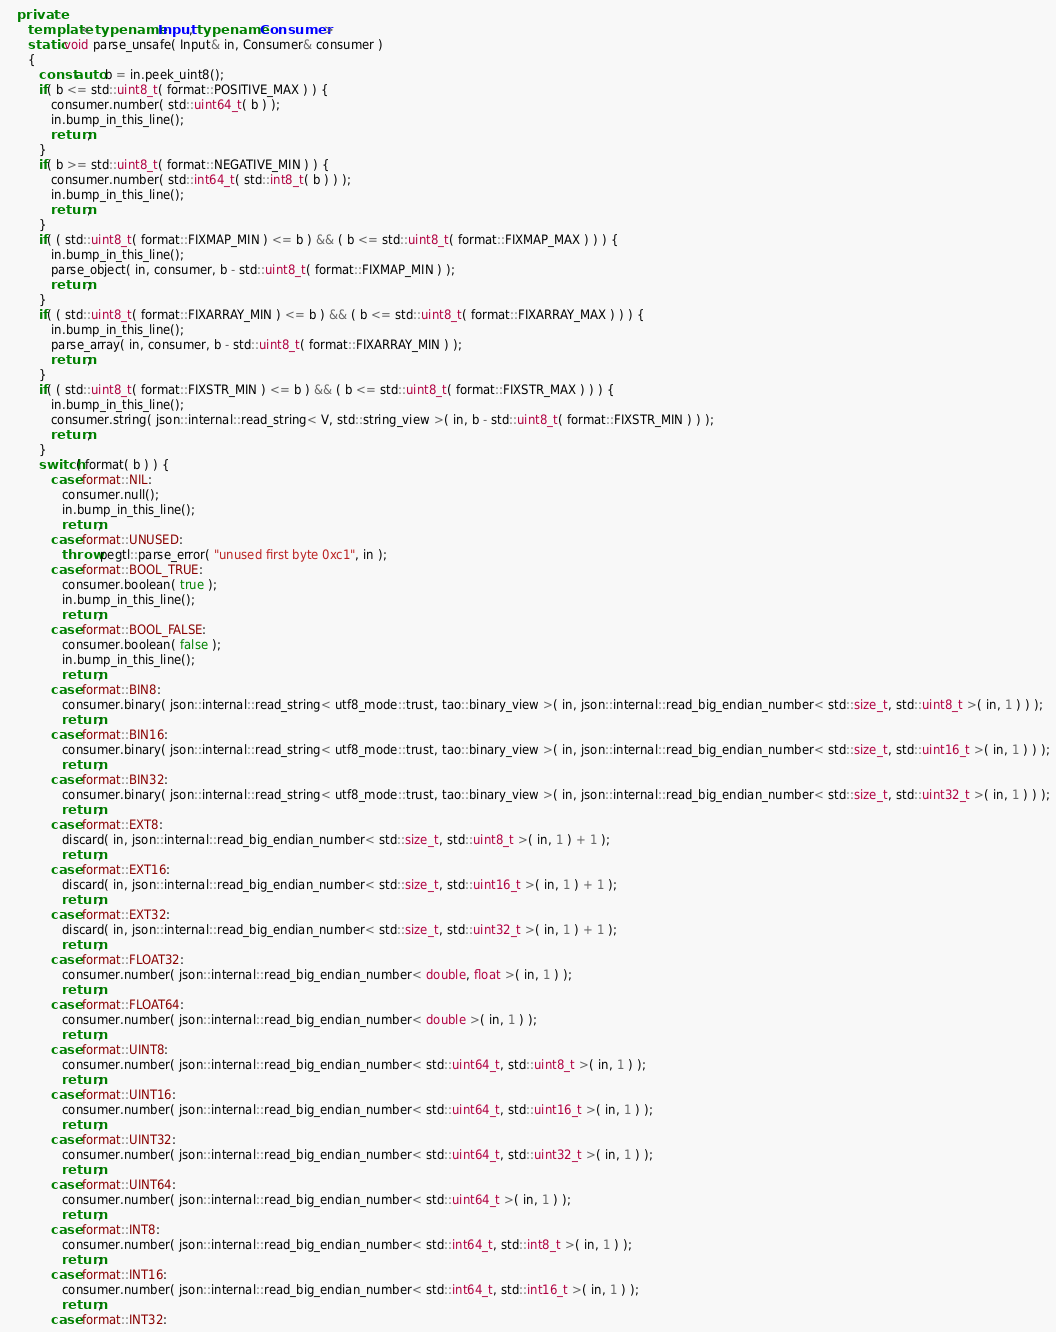Convert code to text. <code><loc_0><loc_0><loc_500><loc_500><_C++_>   private:
      template< typename Input, typename Consumer >
      static void parse_unsafe( Input& in, Consumer& consumer )
      {
         const auto b = in.peek_uint8();
         if( b <= std::uint8_t( format::POSITIVE_MAX ) ) {
            consumer.number( std::uint64_t( b ) );
            in.bump_in_this_line();
            return;
         }
         if( b >= std::uint8_t( format::NEGATIVE_MIN ) ) {
            consumer.number( std::int64_t( std::int8_t( b ) ) );
            in.bump_in_this_line();
            return;
         }
         if( ( std::uint8_t( format::FIXMAP_MIN ) <= b ) && ( b <= std::uint8_t( format::FIXMAP_MAX ) ) ) {
            in.bump_in_this_line();
            parse_object( in, consumer, b - std::uint8_t( format::FIXMAP_MIN ) );
            return;
         }
         if( ( std::uint8_t( format::FIXARRAY_MIN ) <= b ) && ( b <= std::uint8_t( format::FIXARRAY_MAX ) ) ) {
            in.bump_in_this_line();
            parse_array( in, consumer, b - std::uint8_t( format::FIXARRAY_MIN ) );
            return;
         }
         if( ( std::uint8_t( format::FIXSTR_MIN ) <= b ) && ( b <= std::uint8_t( format::FIXSTR_MAX ) ) ) {
            in.bump_in_this_line();
            consumer.string( json::internal::read_string< V, std::string_view >( in, b - std::uint8_t( format::FIXSTR_MIN ) ) );
            return;
         }
         switch( format( b ) ) {
            case format::NIL:
               consumer.null();
               in.bump_in_this_line();
               return;
            case format::UNUSED:
               throw pegtl::parse_error( "unused first byte 0xc1", in );
            case format::BOOL_TRUE:
               consumer.boolean( true );
               in.bump_in_this_line();
               return;
            case format::BOOL_FALSE:
               consumer.boolean( false );
               in.bump_in_this_line();
               return;
            case format::BIN8:
               consumer.binary( json::internal::read_string< utf8_mode::trust, tao::binary_view >( in, json::internal::read_big_endian_number< std::size_t, std::uint8_t >( in, 1 ) ) );
               return;
            case format::BIN16:
               consumer.binary( json::internal::read_string< utf8_mode::trust, tao::binary_view >( in, json::internal::read_big_endian_number< std::size_t, std::uint16_t >( in, 1 ) ) );
               return;
            case format::BIN32:
               consumer.binary( json::internal::read_string< utf8_mode::trust, tao::binary_view >( in, json::internal::read_big_endian_number< std::size_t, std::uint32_t >( in, 1 ) ) );
               return;
            case format::EXT8:
               discard( in, json::internal::read_big_endian_number< std::size_t, std::uint8_t >( in, 1 ) + 1 );
               return;
            case format::EXT16:
               discard( in, json::internal::read_big_endian_number< std::size_t, std::uint16_t >( in, 1 ) + 1 );
               return;
            case format::EXT32:
               discard( in, json::internal::read_big_endian_number< std::size_t, std::uint32_t >( in, 1 ) + 1 );
               return;
            case format::FLOAT32:
               consumer.number( json::internal::read_big_endian_number< double, float >( in, 1 ) );
               return;
            case format::FLOAT64:
               consumer.number( json::internal::read_big_endian_number< double >( in, 1 ) );
               return;
            case format::UINT8:
               consumer.number( json::internal::read_big_endian_number< std::uint64_t, std::uint8_t >( in, 1 ) );
               return;
            case format::UINT16:
               consumer.number( json::internal::read_big_endian_number< std::uint64_t, std::uint16_t >( in, 1 ) );
               return;
            case format::UINT32:
               consumer.number( json::internal::read_big_endian_number< std::uint64_t, std::uint32_t >( in, 1 ) );
               return;
            case format::UINT64:
               consumer.number( json::internal::read_big_endian_number< std::uint64_t >( in, 1 ) );
               return;
            case format::INT8:
               consumer.number( json::internal::read_big_endian_number< std::int64_t, std::int8_t >( in, 1 ) );
               return;
            case format::INT16:
               consumer.number( json::internal::read_big_endian_number< std::int64_t, std::int16_t >( in, 1 ) );
               return;
            case format::INT32:</code> 